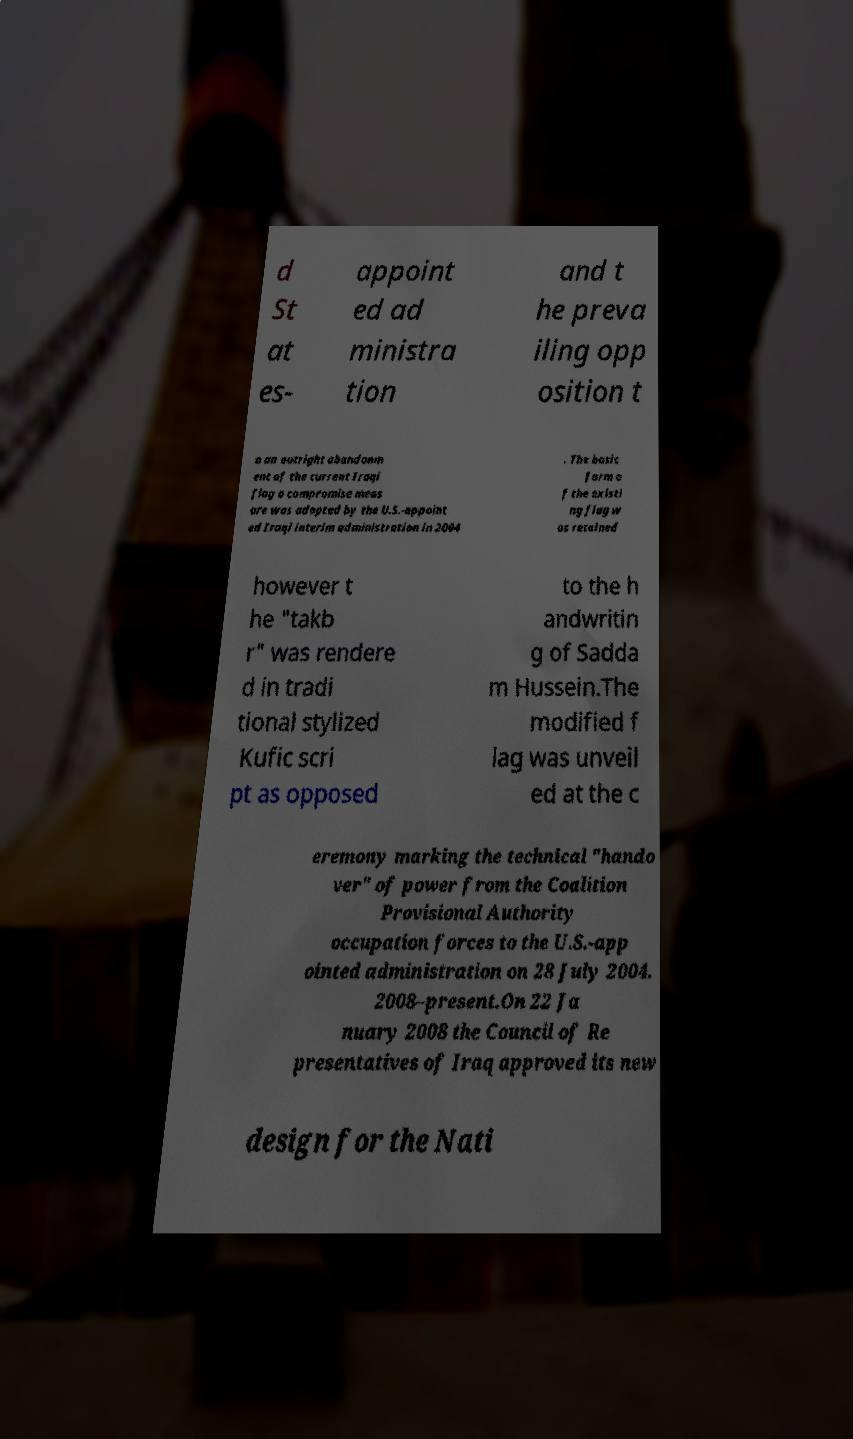For documentation purposes, I need the text within this image transcribed. Could you provide that? d St at es- appoint ed ad ministra tion and t he preva iling opp osition t o an outright abandonm ent of the current Iraqi flag a compromise meas ure was adopted by the U.S.-appoint ed Iraqi interim administration in 2004 . The basic form o f the existi ng flag w as retained however t he "takb r" was rendere d in tradi tional stylized Kufic scri pt as opposed to the h andwritin g of Sadda m Hussein.The modified f lag was unveil ed at the c eremony marking the technical "hando ver" of power from the Coalition Provisional Authority occupation forces to the U.S.-app ointed administration on 28 July 2004. 2008–present.On 22 Ja nuary 2008 the Council of Re presentatives of Iraq approved its new design for the Nati 